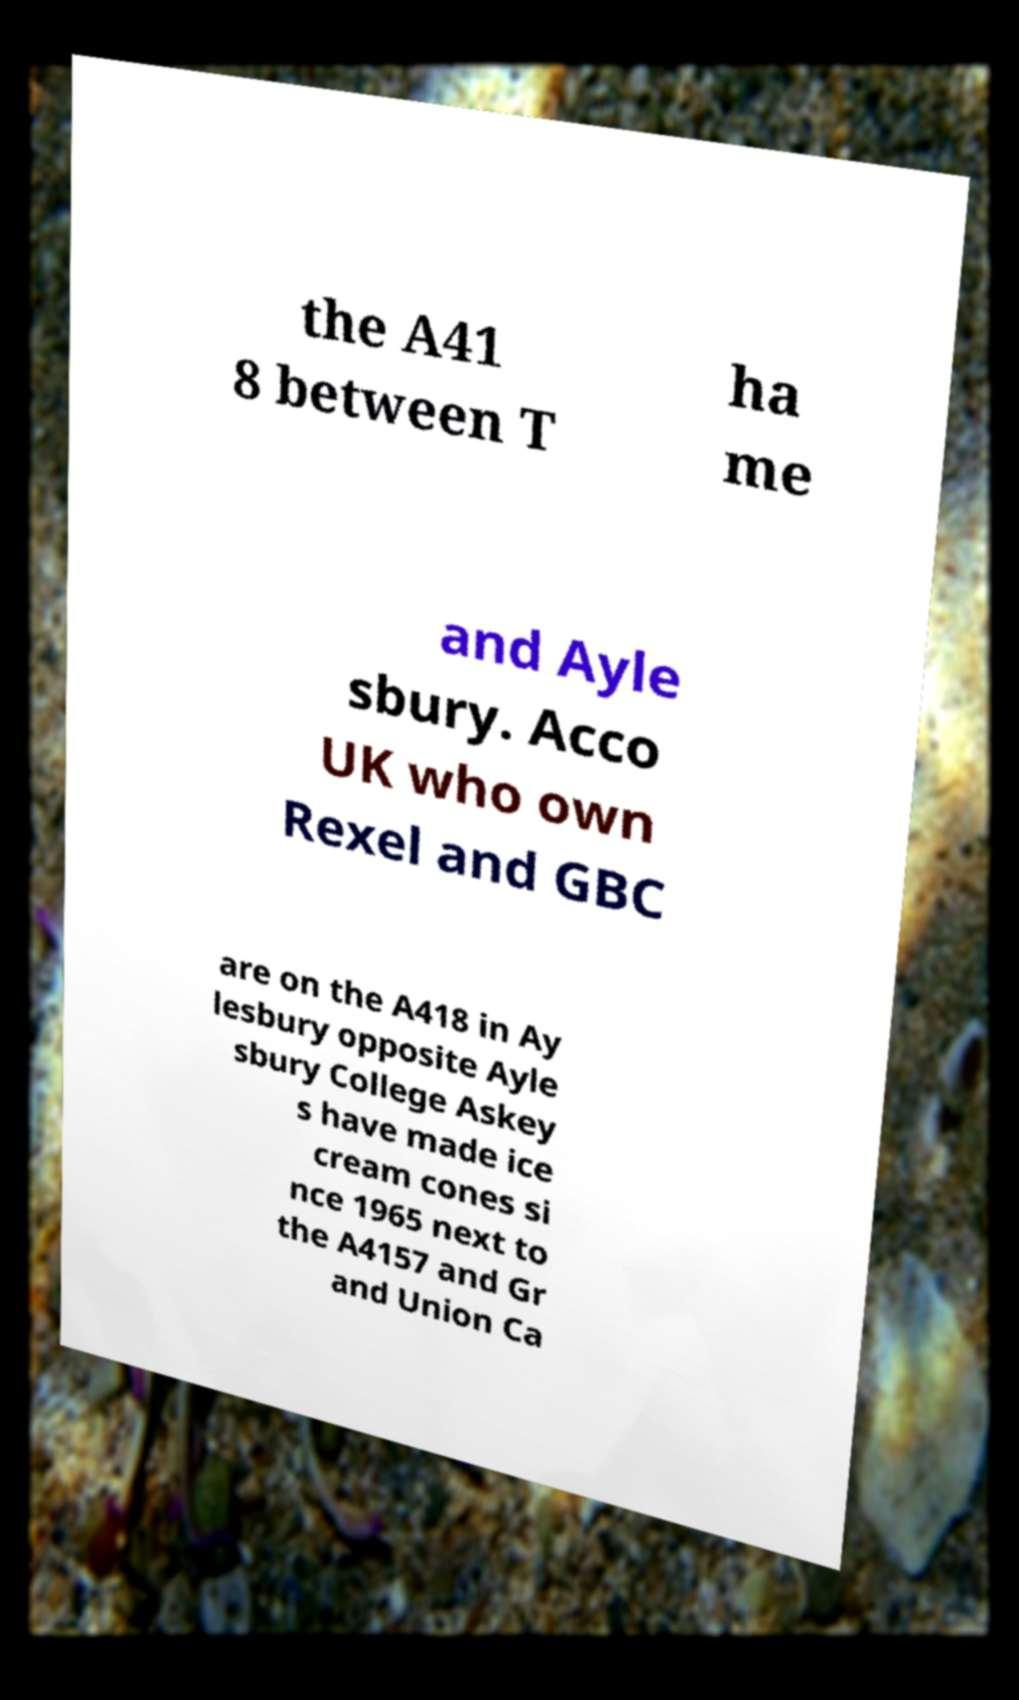I need the written content from this picture converted into text. Can you do that? the A41 8 between T ha me and Ayle sbury. Acco UK who own Rexel and GBC are on the A418 in Ay lesbury opposite Ayle sbury College Askey s have made ice cream cones si nce 1965 next to the A4157 and Gr and Union Ca 